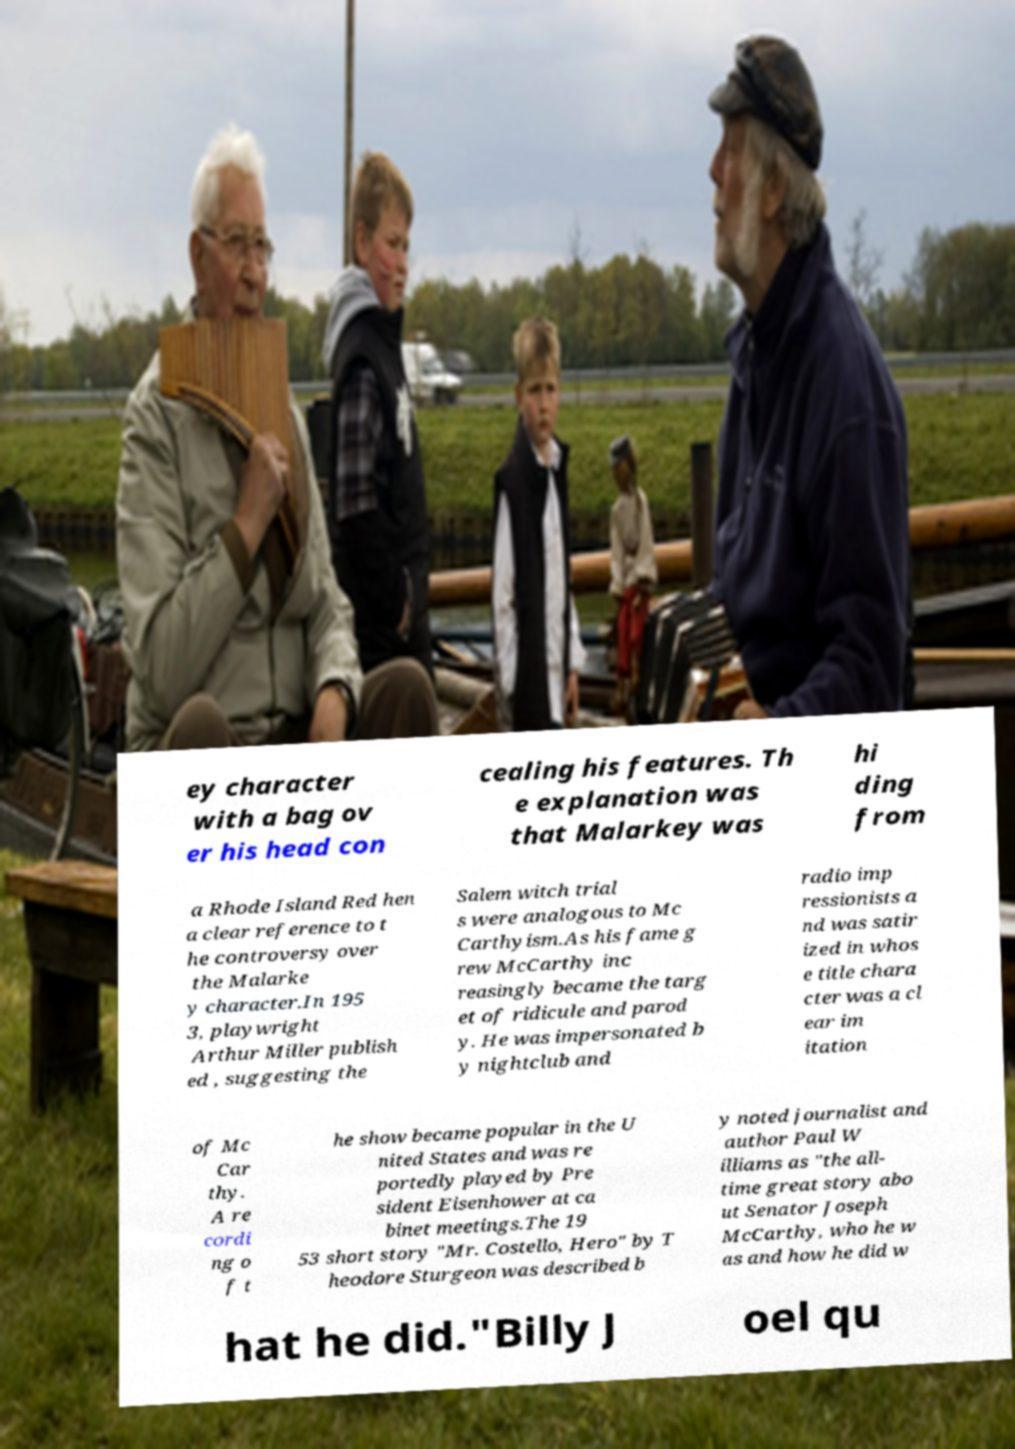Can you accurately transcribe the text from the provided image for me? ey character with a bag ov er his head con cealing his features. Th e explanation was that Malarkey was hi ding from a Rhode Island Red hen a clear reference to t he controversy over the Malarke y character.In 195 3, playwright Arthur Miller publish ed , suggesting the Salem witch trial s were analogous to Mc Carthyism.As his fame g rew McCarthy inc reasingly became the targ et of ridicule and parod y. He was impersonated b y nightclub and radio imp ressionists a nd was satir ized in whos e title chara cter was a cl ear im itation of Mc Car thy. A re cordi ng o f t he show became popular in the U nited States and was re portedly played by Pre sident Eisenhower at ca binet meetings.The 19 53 short story "Mr. Costello, Hero" by T heodore Sturgeon was described b y noted journalist and author Paul W illiams as "the all- time great story abo ut Senator Joseph McCarthy, who he w as and how he did w hat he did."Billy J oel qu 